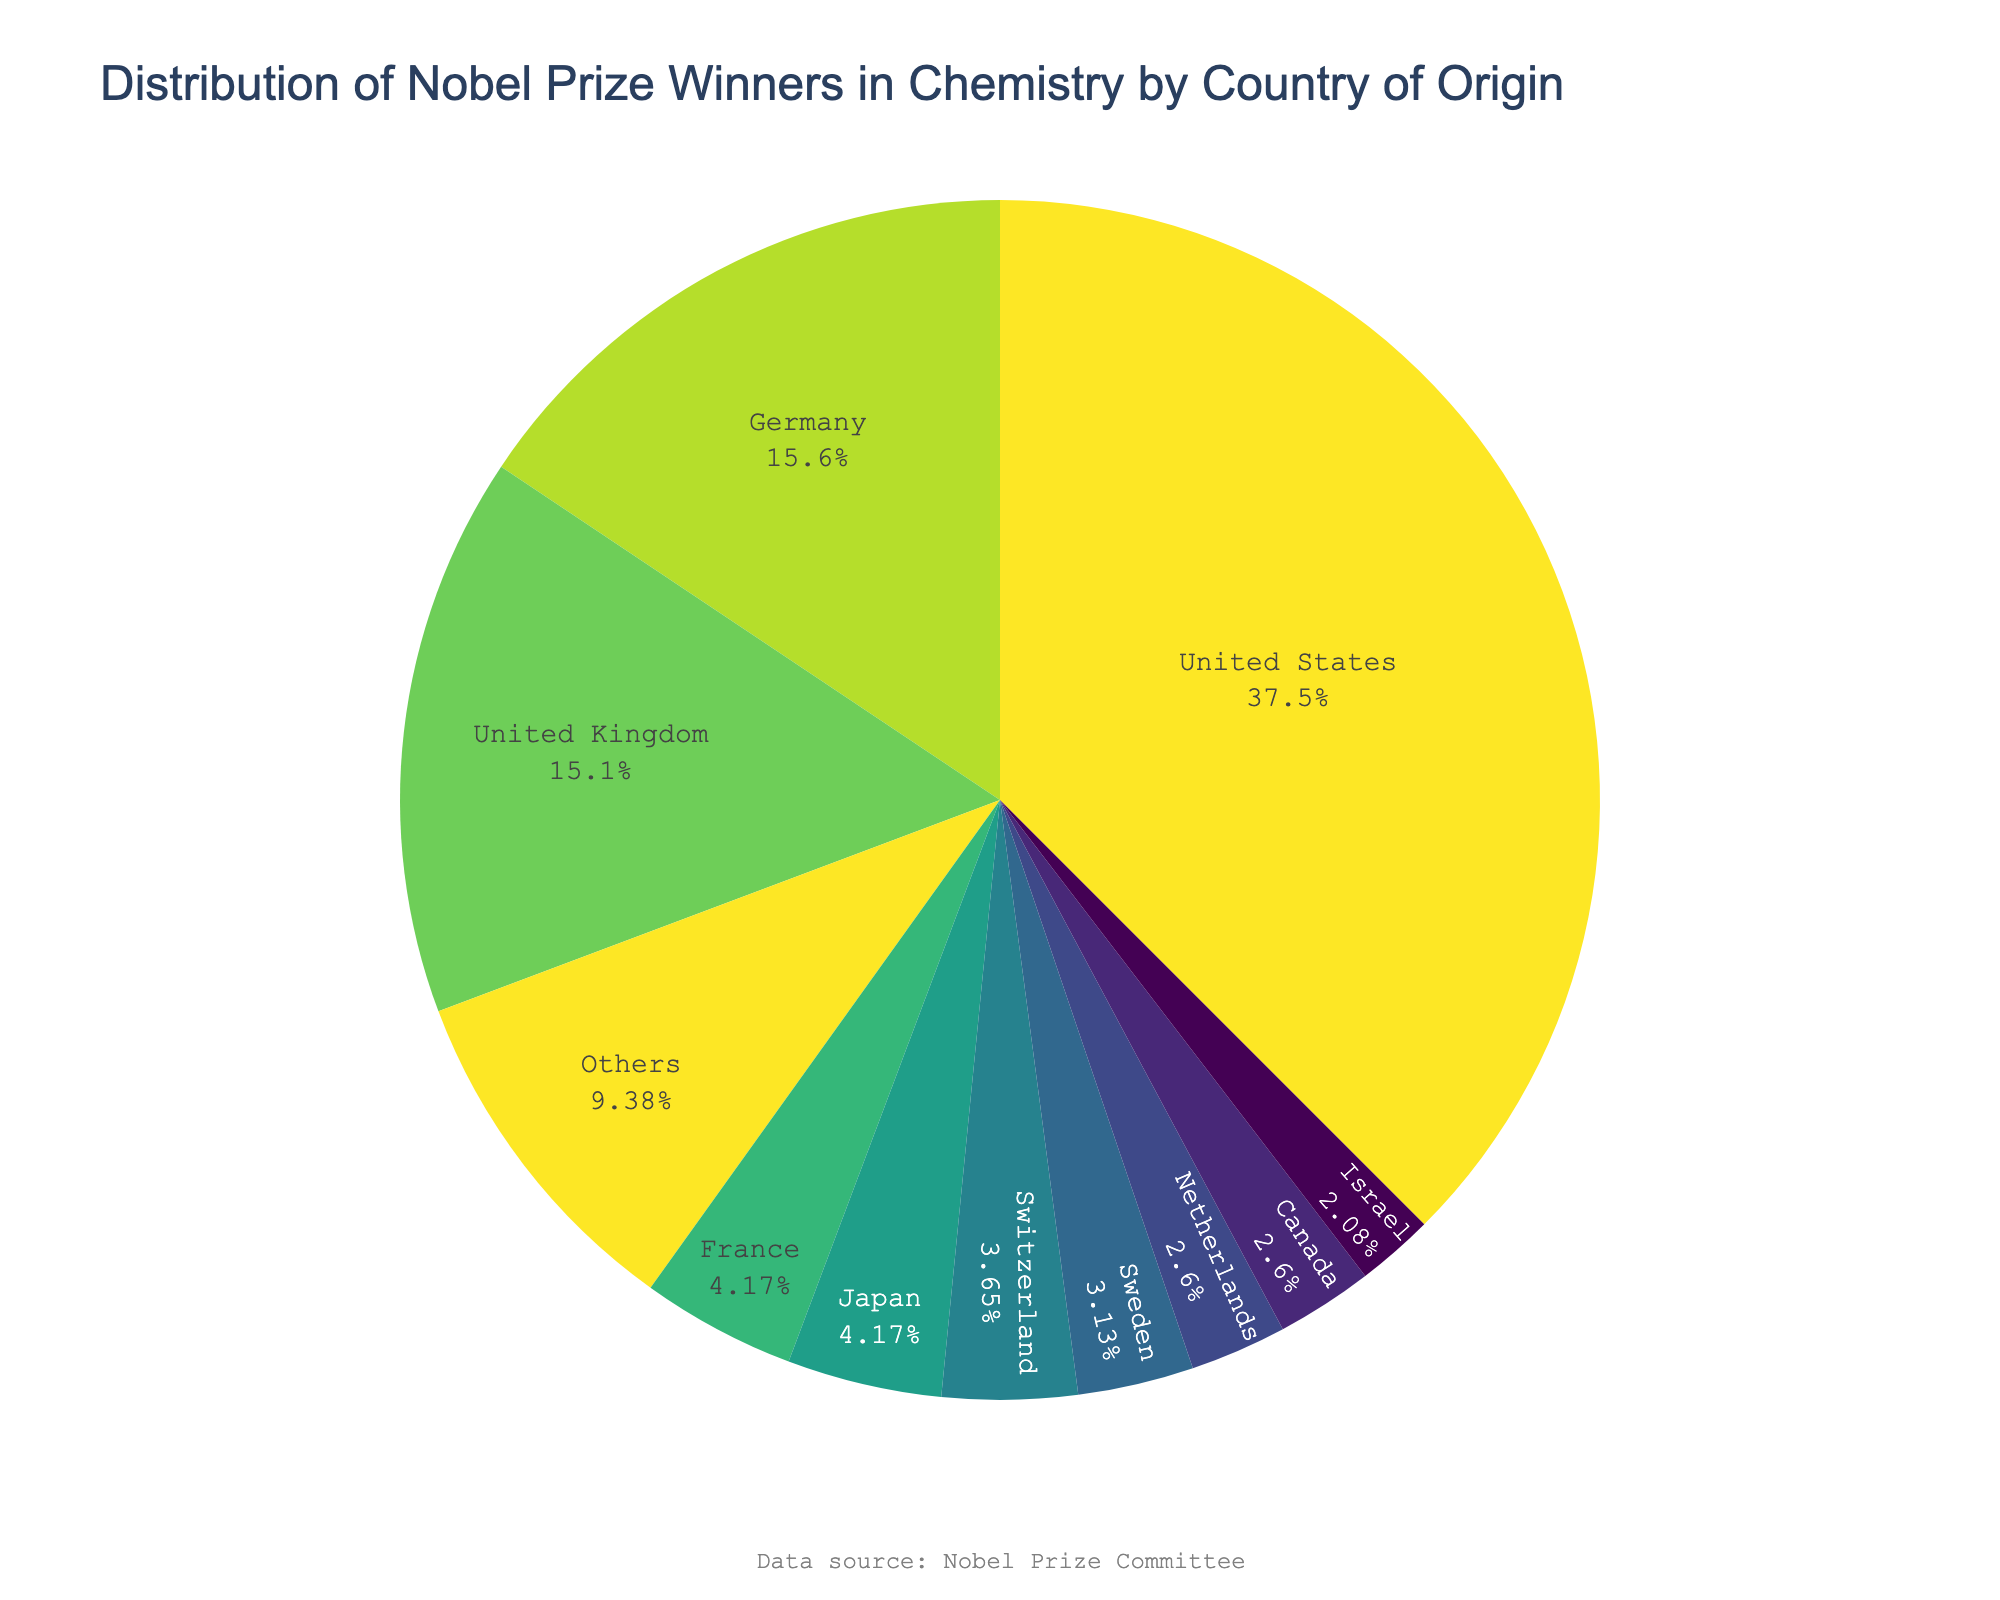Which country has the highest number of Nobel Prize winners in Chemistry? The pie chart shows different countries with the number of Nobel Prize winners. The largest segment is labeled "United States," indicating it has the highest number.
Answer: United States What percentage of Nobel Prize winners in Chemistry is from the United States? The pie chart's segment for the United States shows a label with its percentage. This percentage is calculated as (72/192)*100.
Answer: Approximately 37.5% Which two countries have the closest number of Nobel Prize winners in Chemistry? By looking at the pie chart, compare the segments’ sizes and numbers. The United Kingdom and Germany have 29 and 30 laureates respectively, showing the closest numbers.
Answer: United Kingdom and Germany How many Nobel Prize winners in Chemistry are represented by the "Others" category? The "Others" segment aggregates all laureates from countries not in the top 10. Find this segment, which sums to 17 winners.
Answer: 17 What fraction of Nobel Prize winners in Chemistry comes from countries other than the top 10? Use the "Others" segment. The pie chart shows 17 laureates in "Others" out of a total of 192. The fraction is 17/192.
Answer: Approximately 8.9% Which countries are in the top 10 for Nobel Prize winners in Chemistry? The pie chart labels segments for each of the top 10 countries. Read through these labels to identify the top 10 countries.
Answer: United States, Germany, United Kingdom, France, Japan, Switzerland, Sweden, Netherlands, Canada, Israel Among the top 10 countries, which country has the smallest percentage of Nobel Prize winners in Chemistry? Examine the smallest segment among the top 10 in the pie chart. Israel, with 4 winners, is the smallest percentage.
Answer: Israel Compare the combined total of Nobel Prize winners in Chemistry from Germany and the United Kingdom to that from the United States. Which is greater? Germany and the United Kingdom have a combined total of 30 + 29 = 59. The United States has 72 winners. Comparing 59 to 72, the United States is greater.
Answer: United States How many more Nobel Prize winners in Chemistry does the United States have compared to the sum of Canada and Israel? United States has 72 winners. Canada has 5 and Israel has 4, totaling 9. Calculate the difference: 72 - 9.
Answer: 63 What's the combined percentage of Nobel Prize winners in Chemistry from the top 3 countries? The top 3 countries are the United States, Germany, and the United Kingdom. Sum their percentages: (72/192)*100 + (30/192)*100 + (29/192)*100.
Answer: Approximately 68.2% 